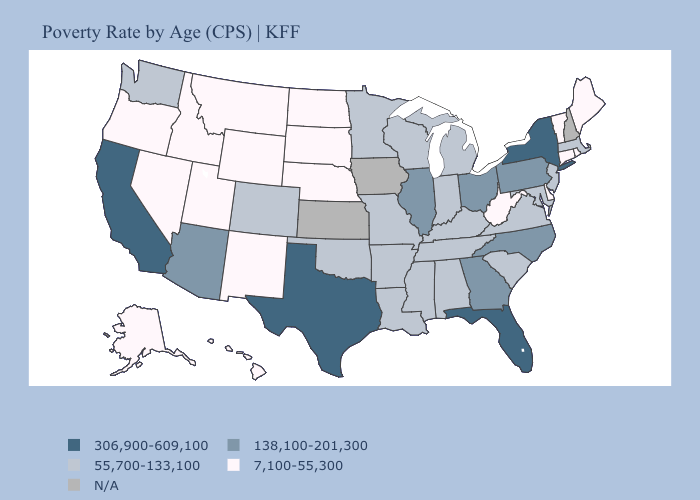What is the value of Washington?
Write a very short answer. 55,700-133,100. Name the states that have a value in the range 306,900-609,100?
Answer briefly. California, Florida, New York, Texas. Name the states that have a value in the range N/A?
Write a very short answer. Iowa, Kansas, New Hampshire. Is the legend a continuous bar?
Short answer required. No. What is the lowest value in the MidWest?
Give a very brief answer. 7,100-55,300. What is the value of Maryland?
Keep it brief. 55,700-133,100. Name the states that have a value in the range 55,700-133,100?
Keep it brief. Alabama, Arkansas, Colorado, Indiana, Kentucky, Louisiana, Maryland, Massachusetts, Michigan, Minnesota, Mississippi, Missouri, New Jersey, Oklahoma, South Carolina, Tennessee, Virginia, Washington, Wisconsin. Among the states that border Massachusetts , does New York have the highest value?
Be succinct. Yes. What is the value of Kansas?
Give a very brief answer. N/A. What is the value of Nevada?
Short answer required. 7,100-55,300. Which states have the lowest value in the USA?
Give a very brief answer. Alaska, Connecticut, Delaware, Hawaii, Idaho, Maine, Montana, Nebraska, Nevada, New Mexico, North Dakota, Oregon, Rhode Island, South Dakota, Utah, Vermont, West Virginia, Wyoming. Does California have the highest value in the USA?
Write a very short answer. Yes. Which states hav the highest value in the West?
Write a very short answer. California. 